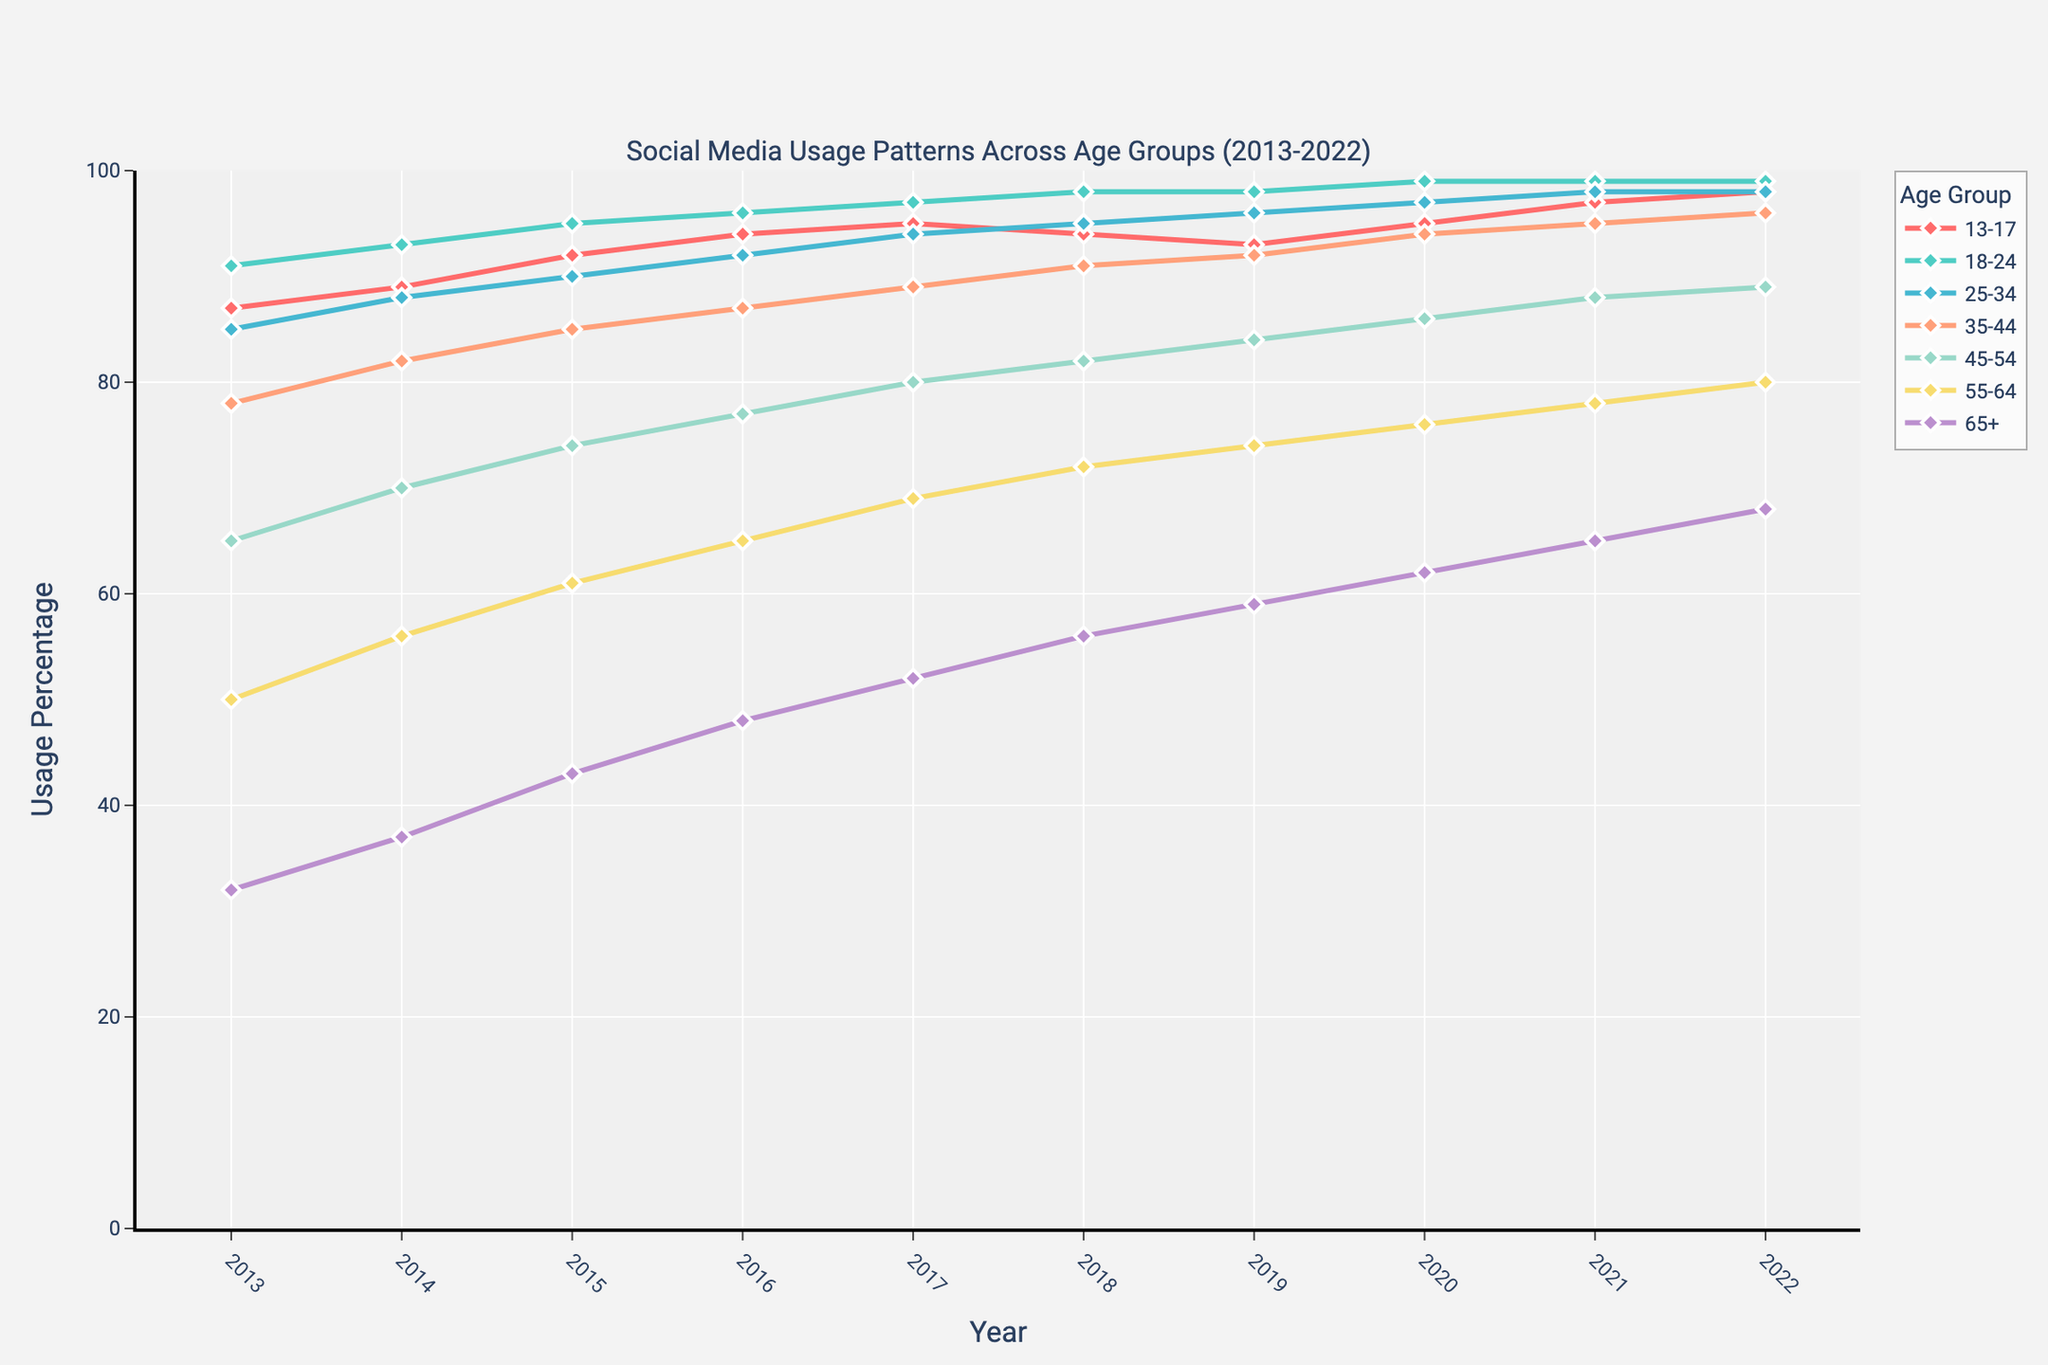What age group had the highest social media usage percentage in 2013? Based on the plot, the line representing the 18-24 age group starts at the highest point in 2013.
Answer: 18-24 Which age group showed the most significant increase in social media usage from 2013 to 2022? To determine this, subtract the 2013 usage percentage from the 2022 usage percentage for each age group and compare. The 65+ age group had an increase from 32% to 68%, which is the most significant increment of 36%.
Answer: 65+ What is the average social media usage percentage for the 25-34 age group over the decade? Sum the values for 2013 to 2022 for the 25-34 age group and then divide by the number of years. (85 + 88 + 90 + 92 + 94 + 95 + 96 + 97 + 98 + 98) / 10 = 93.3
Answer: 93.3 How does the 55-64 age group's social media usage in 2022 compare to that in 2015? Look at the plot for the 55-64 age group and compare the points for 2015 (61%) and 2022 (80%). The increase is 80% - 61% = 19%.
Answer: 19% Which age group consistently had a social media usage percentage of 95% or higher from 2020 to 2022? Identify the age group whose line remains at or above 95% in 2020, 2021, and 2022. The 18-24 age group remains at 99% in these years.
Answer: 18-24 What was the year-on-year increase in social media usage for the 45-54 age group from 2013 to 2014? Subtract the value for 2013 (65%) from the value for 2014 (70%). The difference is 70% - 65% = 5%.
Answer: 5% Which two age groups had similar social media usage percentages in 2022? Compare the 2022 values for each age group. The 13-17 and 25-34 age groups both had 98% usage in 2022.
Answer: 13-17, 25-34 What is the overall trend for the social media usage of the 35-44 age group from 2013 to 2022? The plot shows that the percentage increased steadily each year from 78% in 2013 to 96% in 2022, indicating an upward trend.
Answer: Upward trend In which year did the 65+ age group first exceed 50% social media usage? Observe the plot for the 65+ age group and identify the first year the usage is above 50%. This occurred in 2017, where the usage is 52%.
Answer: 2017 Between which years did the 13-17 age group experience the only decline in social media usage? Look for the years where the line for the 13-17 age group dips. The only decrease is from 2017 (95%) to 2018 (94%).
Answer: 2017-2018 